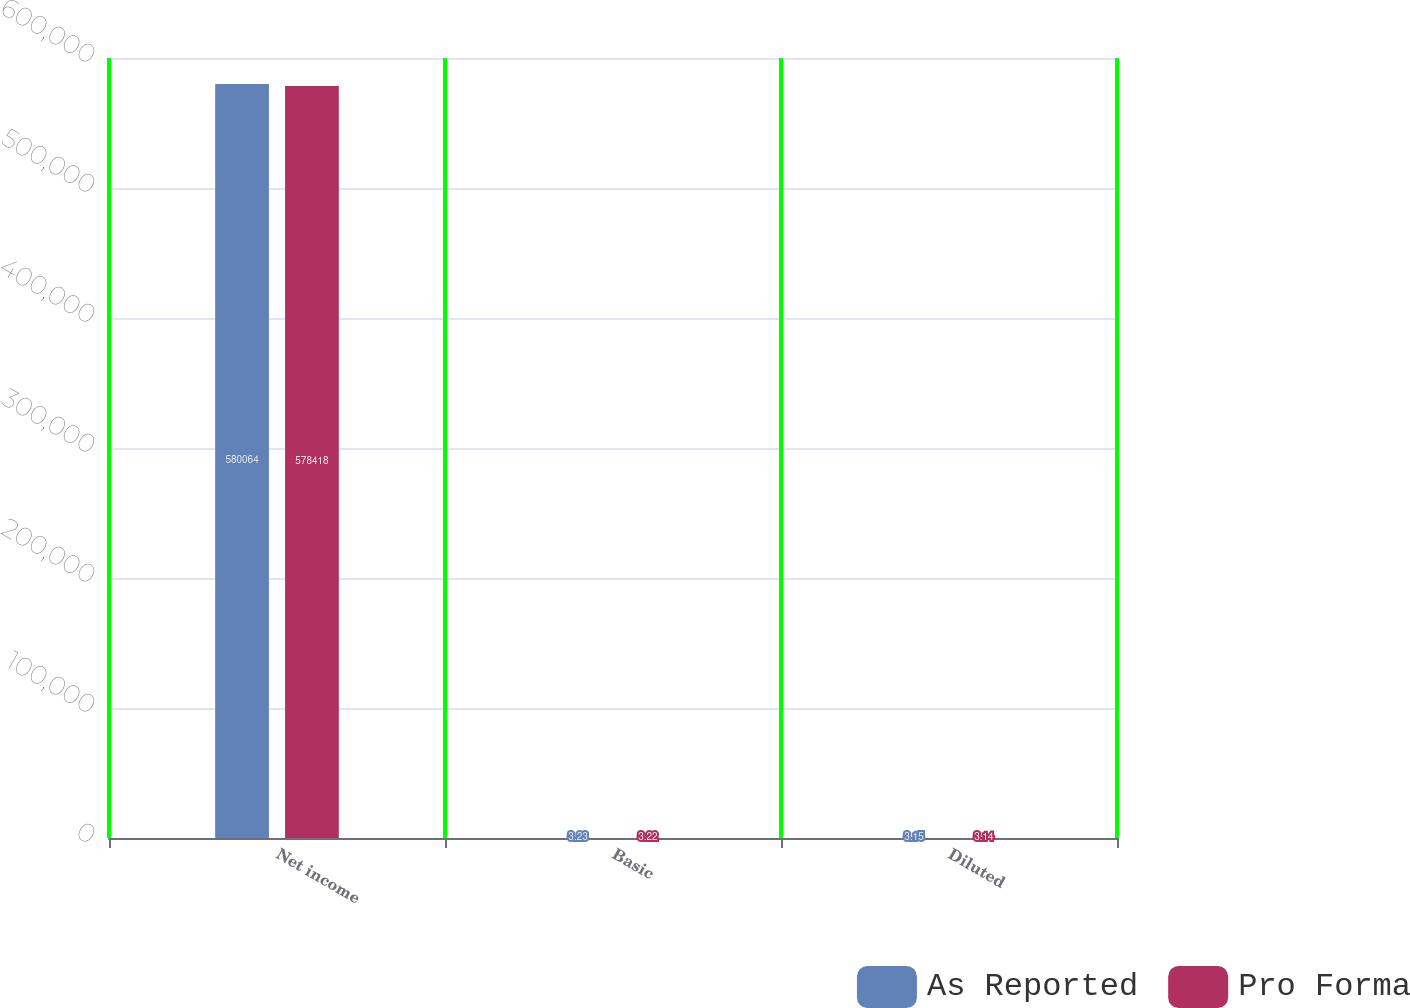Convert chart to OTSL. <chart><loc_0><loc_0><loc_500><loc_500><stacked_bar_chart><ecel><fcel>Net income<fcel>Basic<fcel>Diluted<nl><fcel>As Reported<fcel>580064<fcel>3.23<fcel>3.15<nl><fcel>Pro Forma<fcel>578418<fcel>3.22<fcel>3.14<nl></chart> 